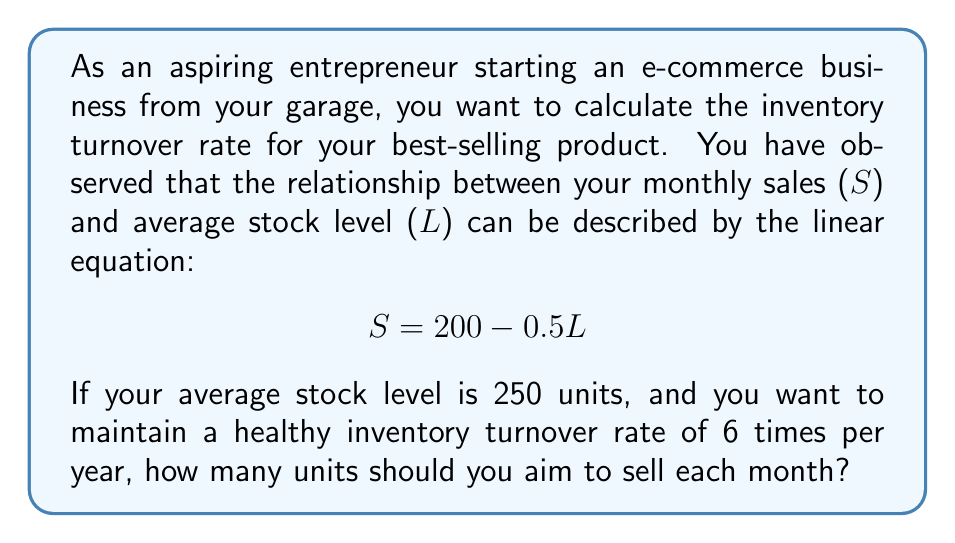Could you help me with this problem? Let's approach this step-by-step:

1) First, recall that the inventory turnover rate is calculated as:

   $\text{Inventory Turnover Rate} = \frac{\text{Annual Sales}}{\text{Average Inventory}}$

2) We're given that the desired inventory turnover rate is 6 times per year, and the average stock level (L) is 250 units. Let's denote monthly sales as S. We can set up the equation:

   $6 = \frac{12S}{250}$

   Here, 12S represents annual sales (monthly sales multiplied by 12 months).

3) Solve this equation for S:

   $6 \cdot 250 = 12S$
   $1500 = 12S$
   $S = 125$

4) Now, we need to verify if this aligns with the given linear relationship between sales and stock level:

   $S = 200 - 0.5L$

5) Substitute L = 250 and S = 125 into this equation:

   $125 = 200 - 0.5(250)$
   $125 = 200 - 125$
   $125 = 125$

6) The equation holds true, confirming that 125 units per month is the correct sales target.
Answer: To maintain an inventory turnover rate of 6 times per year with an average stock level of 250 units, you should aim to sell 125 units each month. 